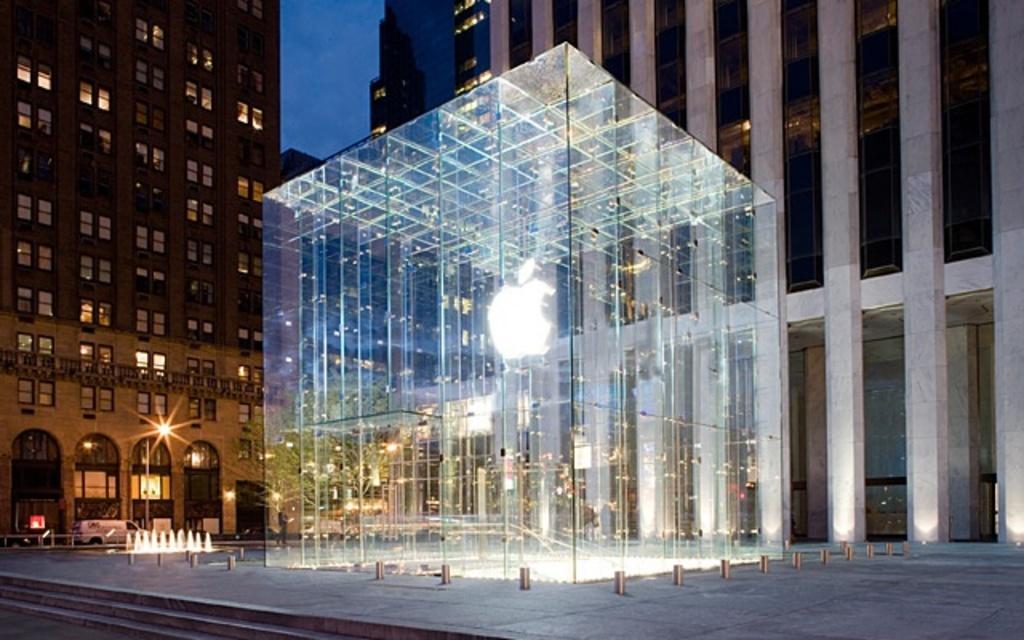Can you describe this image briefly? In the middle of the image I can see a room which is made up of glass. In the background, I can see the buildings. At the bottom of the image there are some stairs. This is an image clicked in the dark. At the top of the image I can see the sky. 